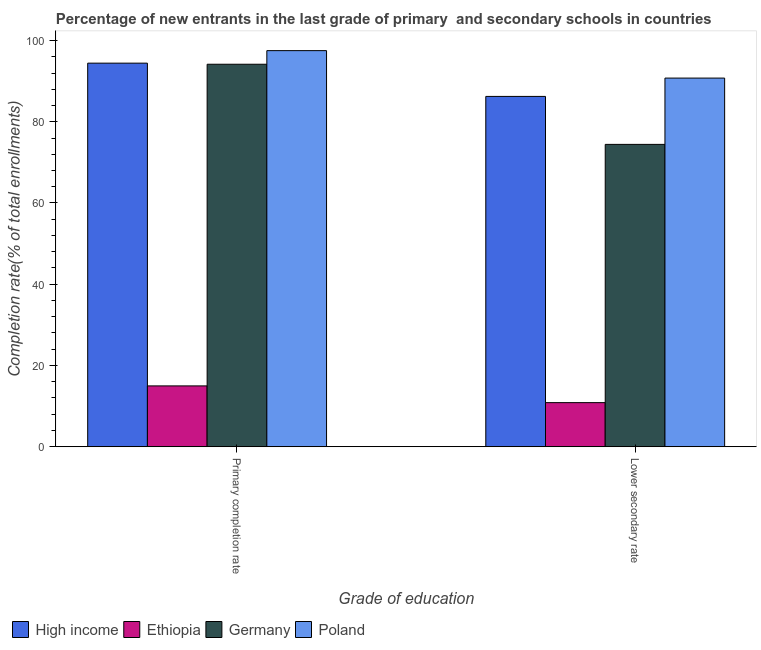How many different coloured bars are there?
Make the answer very short. 4. Are the number of bars per tick equal to the number of legend labels?
Your answer should be very brief. Yes. Are the number of bars on each tick of the X-axis equal?
Give a very brief answer. Yes. How many bars are there on the 2nd tick from the left?
Keep it short and to the point. 4. How many bars are there on the 2nd tick from the right?
Your answer should be very brief. 4. What is the label of the 2nd group of bars from the left?
Keep it short and to the point. Lower secondary rate. What is the completion rate in secondary schools in Poland?
Offer a very short reply. 90.75. Across all countries, what is the maximum completion rate in secondary schools?
Give a very brief answer. 90.75. Across all countries, what is the minimum completion rate in primary schools?
Your answer should be very brief. 14.97. In which country was the completion rate in secondary schools minimum?
Ensure brevity in your answer.  Ethiopia. What is the total completion rate in secondary schools in the graph?
Your response must be concise. 262.27. What is the difference between the completion rate in secondary schools in Poland and that in Ethiopia?
Make the answer very short. 79.9. What is the difference between the completion rate in primary schools in Germany and the completion rate in secondary schools in Ethiopia?
Offer a terse response. 83.3. What is the average completion rate in secondary schools per country?
Offer a very short reply. 65.57. What is the difference between the completion rate in secondary schools and completion rate in primary schools in Poland?
Provide a short and direct response. -6.76. In how many countries, is the completion rate in primary schools greater than 8 %?
Ensure brevity in your answer.  4. What is the ratio of the completion rate in primary schools in High income to that in Poland?
Your answer should be compact. 0.97. Is the completion rate in secondary schools in Poland less than that in Ethiopia?
Provide a succinct answer. No. What does the 1st bar from the left in Lower secondary rate represents?
Your response must be concise. High income. What does the 3rd bar from the right in Primary completion rate represents?
Your response must be concise. Ethiopia. Are all the bars in the graph horizontal?
Your answer should be compact. No. What is the difference between two consecutive major ticks on the Y-axis?
Your response must be concise. 20. Are the values on the major ticks of Y-axis written in scientific E-notation?
Give a very brief answer. No. Does the graph contain any zero values?
Provide a short and direct response. No. Does the graph contain grids?
Your answer should be very brief. No. How many legend labels are there?
Your answer should be very brief. 4. What is the title of the graph?
Give a very brief answer. Percentage of new entrants in the last grade of primary  and secondary schools in countries. Does "Andorra" appear as one of the legend labels in the graph?
Offer a terse response. No. What is the label or title of the X-axis?
Offer a very short reply. Grade of education. What is the label or title of the Y-axis?
Provide a succinct answer. Completion rate(% of total enrollments). What is the Completion rate(% of total enrollments) in High income in Primary completion rate?
Your response must be concise. 94.43. What is the Completion rate(% of total enrollments) of Ethiopia in Primary completion rate?
Offer a very short reply. 14.97. What is the Completion rate(% of total enrollments) in Germany in Primary completion rate?
Your answer should be very brief. 94.16. What is the Completion rate(% of total enrollments) in Poland in Primary completion rate?
Give a very brief answer. 97.51. What is the Completion rate(% of total enrollments) in High income in Lower secondary rate?
Give a very brief answer. 86.24. What is the Completion rate(% of total enrollments) of Ethiopia in Lower secondary rate?
Give a very brief answer. 10.85. What is the Completion rate(% of total enrollments) of Germany in Lower secondary rate?
Offer a very short reply. 74.43. What is the Completion rate(% of total enrollments) of Poland in Lower secondary rate?
Your answer should be compact. 90.75. Across all Grade of education, what is the maximum Completion rate(% of total enrollments) of High income?
Your response must be concise. 94.43. Across all Grade of education, what is the maximum Completion rate(% of total enrollments) of Ethiopia?
Your response must be concise. 14.97. Across all Grade of education, what is the maximum Completion rate(% of total enrollments) in Germany?
Your answer should be very brief. 94.16. Across all Grade of education, what is the maximum Completion rate(% of total enrollments) of Poland?
Keep it short and to the point. 97.51. Across all Grade of education, what is the minimum Completion rate(% of total enrollments) in High income?
Make the answer very short. 86.24. Across all Grade of education, what is the minimum Completion rate(% of total enrollments) of Ethiopia?
Provide a short and direct response. 10.85. Across all Grade of education, what is the minimum Completion rate(% of total enrollments) of Germany?
Offer a terse response. 74.43. Across all Grade of education, what is the minimum Completion rate(% of total enrollments) of Poland?
Your answer should be very brief. 90.75. What is the total Completion rate(% of total enrollments) of High income in the graph?
Keep it short and to the point. 180.67. What is the total Completion rate(% of total enrollments) in Ethiopia in the graph?
Give a very brief answer. 25.83. What is the total Completion rate(% of total enrollments) in Germany in the graph?
Your answer should be compact. 168.59. What is the total Completion rate(% of total enrollments) of Poland in the graph?
Offer a very short reply. 188.26. What is the difference between the Completion rate(% of total enrollments) of High income in Primary completion rate and that in Lower secondary rate?
Offer a terse response. 8.19. What is the difference between the Completion rate(% of total enrollments) of Ethiopia in Primary completion rate and that in Lower secondary rate?
Ensure brevity in your answer.  4.12. What is the difference between the Completion rate(% of total enrollments) in Germany in Primary completion rate and that in Lower secondary rate?
Your response must be concise. 19.73. What is the difference between the Completion rate(% of total enrollments) of Poland in Primary completion rate and that in Lower secondary rate?
Ensure brevity in your answer.  6.76. What is the difference between the Completion rate(% of total enrollments) in High income in Primary completion rate and the Completion rate(% of total enrollments) in Ethiopia in Lower secondary rate?
Offer a terse response. 83.57. What is the difference between the Completion rate(% of total enrollments) of High income in Primary completion rate and the Completion rate(% of total enrollments) of Germany in Lower secondary rate?
Offer a terse response. 20. What is the difference between the Completion rate(% of total enrollments) in High income in Primary completion rate and the Completion rate(% of total enrollments) in Poland in Lower secondary rate?
Offer a very short reply. 3.68. What is the difference between the Completion rate(% of total enrollments) in Ethiopia in Primary completion rate and the Completion rate(% of total enrollments) in Germany in Lower secondary rate?
Make the answer very short. -59.45. What is the difference between the Completion rate(% of total enrollments) of Ethiopia in Primary completion rate and the Completion rate(% of total enrollments) of Poland in Lower secondary rate?
Make the answer very short. -75.78. What is the difference between the Completion rate(% of total enrollments) of Germany in Primary completion rate and the Completion rate(% of total enrollments) of Poland in Lower secondary rate?
Your answer should be very brief. 3.41. What is the average Completion rate(% of total enrollments) of High income per Grade of education?
Offer a terse response. 90.33. What is the average Completion rate(% of total enrollments) of Ethiopia per Grade of education?
Give a very brief answer. 12.91. What is the average Completion rate(% of total enrollments) of Germany per Grade of education?
Keep it short and to the point. 84.29. What is the average Completion rate(% of total enrollments) of Poland per Grade of education?
Your answer should be compact. 94.13. What is the difference between the Completion rate(% of total enrollments) in High income and Completion rate(% of total enrollments) in Ethiopia in Primary completion rate?
Provide a succinct answer. 79.45. What is the difference between the Completion rate(% of total enrollments) of High income and Completion rate(% of total enrollments) of Germany in Primary completion rate?
Provide a short and direct response. 0.27. What is the difference between the Completion rate(% of total enrollments) of High income and Completion rate(% of total enrollments) of Poland in Primary completion rate?
Your answer should be very brief. -3.08. What is the difference between the Completion rate(% of total enrollments) of Ethiopia and Completion rate(% of total enrollments) of Germany in Primary completion rate?
Make the answer very short. -79.18. What is the difference between the Completion rate(% of total enrollments) of Ethiopia and Completion rate(% of total enrollments) of Poland in Primary completion rate?
Give a very brief answer. -82.54. What is the difference between the Completion rate(% of total enrollments) in Germany and Completion rate(% of total enrollments) in Poland in Primary completion rate?
Your answer should be compact. -3.35. What is the difference between the Completion rate(% of total enrollments) in High income and Completion rate(% of total enrollments) in Ethiopia in Lower secondary rate?
Offer a terse response. 75.39. What is the difference between the Completion rate(% of total enrollments) of High income and Completion rate(% of total enrollments) of Germany in Lower secondary rate?
Provide a succinct answer. 11.81. What is the difference between the Completion rate(% of total enrollments) in High income and Completion rate(% of total enrollments) in Poland in Lower secondary rate?
Provide a succinct answer. -4.51. What is the difference between the Completion rate(% of total enrollments) of Ethiopia and Completion rate(% of total enrollments) of Germany in Lower secondary rate?
Keep it short and to the point. -63.57. What is the difference between the Completion rate(% of total enrollments) of Ethiopia and Completion rate(% of total enrollments) of Poland in Lower secondary rate?
Offer a very short reply. -79.9. What is the difference between the Completion rate(% of total enrollments) of Germany and Completion rate(% of total enrollments) of Poland in Lower secondary rate?
Your answer should be very brief. -16.32. What is the ratio of the Completion rate(% of total enrollments) of High income in Primary completion rate to that in Lower secondary rate?
Offer a terse response. 1.09. What is the ratio of the Completion rate(% of total enrollments) of Ethiopia in Primary completion rate to that in Lower secondary rate?
Offer a terse response. 1.38. What is the ratio of the Completion rate(% of total enrollments) of Germany in Primary completion rate to that in Lower secondary rate?
Give a very brief answer. 1.27. What is the ratio of the Completion rate(% of total enrollments) in Poland in Primary completion rate to that in Lower secondary rate?
Provide a short and direct response. 1.07. What is the difference between the highest and the second highest Completion rate(% of total enrollments) in High income?
Offer a terse response. 8.19. What is the difference between the highest and the second highest Completion rate(% of total enrollments) of Ethiopia?
Keep it short and to the point. 4.12. What is the difference between the highest and the second highest Completion rate(% of total enrollments) in Germany?
Make the answer very short. 19.73. What is the difference between the highest and the second highest Completion rate(% of total enrollments) of Poland?
Keep it short and to the point. 6.76. What is the difference between the highest and the lowest Completion rate(% of total enrollments) in High income?
Your answer should be compact. 8.19. What is the difference between the highest and the lowest Completion rate(% of total enrollments) in Ethiopia?
Offer a terse response. 4.12. What is the difference between the highest and the lowest Completion rate(% of total enrollments) in Germany?
Give a very brief answer. 19.73. What is the difference between the highest and the lowest Completion rate(% of total enrollments) of Poland?
Ensure brevity in your answer.  6.76. 